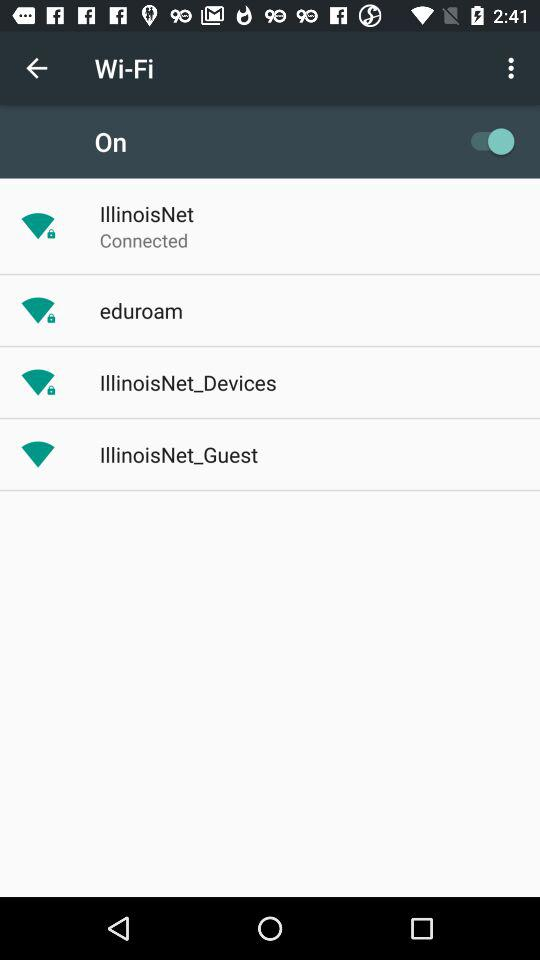Which Wi-Fi networks are available? The available Wi-Fi networks are "IllinoisNet", "eduroam", "IllinoisNet_Devices" and "IllinoisNet_Guest". 